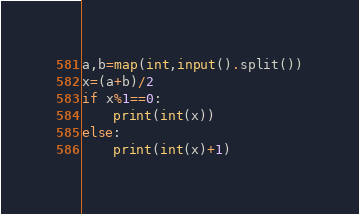<code> <loc_0><loc_0><loc_500><loc_500><_Python_>a,b=map(int,input().split())
x=(a+b)/2
if x%1==0:
    print(int(x))
else:
    print(int(x)+1)</code> 